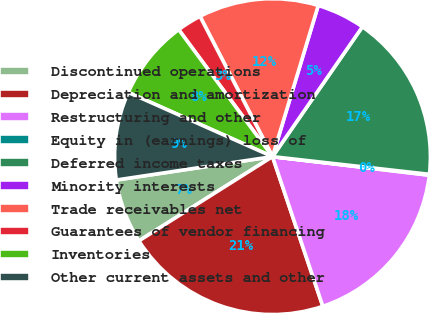Convert chart to OTSL. <chart><loc_0><loc_0><loc_500><loc_500><pie_chart><fcel>Discontinued operations<fcel>Depreciation and amortization<fcel>Restructuring and other<fcel>Equity in (earnings) loss of<fcel>Deferred income taxes<fcel>Minority interests<fcel>Trade receivables net<fcel>Guarantees of vendor financing<fcel>Inventories<fcel>Other current assets and other<nl><fcel>6.59%<fcel>21.21%<fcel>17.96%<fcel>0.09%<fcel>17.15%<fcel>4.96%<fcel>12.27%<fcel>2.53%<fcel>8.21%<fcel>9.03%<nl></chart> 